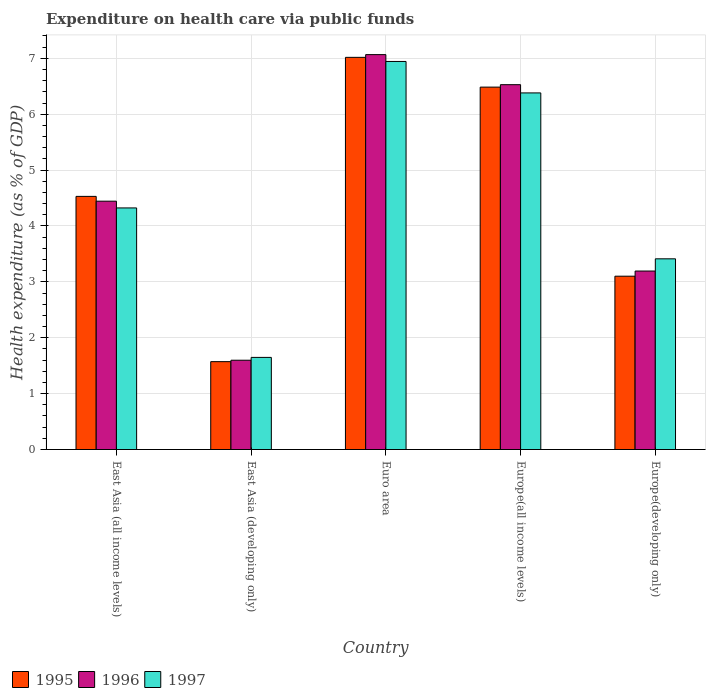How many different coloured bars are there?
Offer a terse response. 3. How many groups of bars are there?
Your response must be concise. 5. Are the number of bars per tick equal to the number of legend labels?
Provide a short and direct response. Yes. How many bars are there on the 3rd tick from the right?
Your answer should be very brief. 3. What is the label of the 4th group of bars from the left?
Ensure brevity in your answer.  Europe(all income levels). In how many cases, is the number of bars for a given country not equal to the number of legend labels?
Keep it short and to the point. 0. What is the expenditure made on health care in 1995 in Euro area?
Give a very brief answer. 7.02. Across all countries, what is the maximum expenditure made on health care in 1997?
Give a very brief answer. 6.94. Across all countries, what is the minimum expenditure made on health care in 1995?
Keep it short and to the point. 1.57. In which country was the expenditure made on health care in 1995 maximum?
Keep it short and to the point. Euro area. In which country was the expenditure made on health care in 1996 minimum?
Your answer should be compact. East Asia (developing only). What is the total expenditure made on health care in 1996 in the graph?
Offer a very short reply. 22.83. What is the difference between the expenditure made on health care in 1996 in East Asia (developing only) and that in Europe(all income levels)?
Your answer should be compact. -4.93. What is the difference between the expenditure made on health care in 1995 in East Asia (all income levels) and the expenditure made on health care in 1997 in Euro area?
Provide a short and direct response. -2.41. What is the average expenditure made on health care in 1995 per country?
Ensure brevity in your answer.  4.54. What is the difference between the expenditure made on health care of/in 1996 and expenditure made on health care of/in 1997 in East Asia (developing only)?
Provide a succinct answer. -0.05. What is the ratio of the expenditure made on health care in 1996 in East Asia (developing only) to that in Euro area?
Your response must be concise. 0.23. Is the expenditure made on health care in 1996 in Europe(all income levels) less than that in Europe(developing only)?
Make the answer very short. No. What is the difference between the highest and the second highest expenditure made on health care in 1997?
Ensure brevity in your answer.  -2.62. What is the difference between the highest and the lowest expenditure made on health care in 1996?
Give a very brief answer. 5.47. In how many countries, is the expenditure made on health care in 1995 greater than the average expenditure made on health care in 1995 taken over all countries?
Keep it short and to the point. 2. What does the 2nd bar from the left in East Asia (developing only) represents?
Provide a succinct answer. 1996. What does the 2nd bar from the right in Europe(all income levels) represents?
Offer a very short reply. 1996. Is it the case that in every country, the sum of the expenditure made on health care in 1996 and expenditure made on health care in 1995 is greater than the expenditure made on health care in 1997?
Your answer should be compact. Yes. How many bars are there?
Provide a short and direct response. 15. How many countries are there in the graph?
Offer a very short reply. 5. Does the graph contain grids?
Provide a succinct answer. Yes. How are the legend labels stacked?
Make the answer very short. Horizontal. What is the title of the graph?
Ensure brevity in your answer.  Expenditure on health care via public funds. What is the label or title of the Y-axis?
Offer a very short reply. Health expenditure (as % of GDP). What is the Health expenditure (as % of GDP) of 1995 in East Asia (all income levels)?
Keep it short and to the point. 4.53. What is the Health expenditure (as % of GDP) of 1996 in East Asia (all income levels)?
Ensure brevity in your answer.  4.44. What is the Health expenditure (as % of GDP) of 1997 in East Asia (all income levels)?
Ensure brevity in your answer.  4.32. What is the Health expenditure (as % of GDP) of 1995 in East Asia (developing only)?
Make the answer very short. 1.57. What is the Health expenditure (as % of GDP) of 1996 in East Asia (developing only)?
Your response must be concise. 1.6. What is the Health expenditure (as % of GDP) of 1997 in East Asia (developing only)?
Offer a terse response. 1.65. What is the Health expenditure (as % of GDP) of 1995 in Euro area?
Your answer should be very brief. 7.02. What is the Health expenditure (as % of GDP) in 1996 in Euro area?
Offer a terse response. 7.07. What is the Health expenditure (as % of GDP) of 1997 in Euro area?
Your answer should be compact. 6.94. What is the Health expenditure (as % of GDP) of 1995 in Europe(all income levels)?
Ensure brevity in your answer.  6.48. What is the Health expenditure (as % of GDP) in 1996 in Europe(all income levels)?
Provide a succinct answer. 6.53. What is the Health expenditure (as % of GDP) in 1997 in Europe(all income levels)?
Make the answer very short. 6.38. What is the Health expenditure (as % of GDP) of 1995 in Europe(developing only)?
Provide a succinct answer. 3.1. What is the Health expenditure (as % of GDP) in 1996 in Europe(developing only)?
Offer a very short reply. 3.19. What is the Health expenditure (as % of GDP) of 1997 in Europe(developing only)?
Provide a short and direct response. 3.41. Across all countries, what is the maximum Health expenditure (as % of GDP) in 1995?
Your answer should be compact. 7.02. Across all countries, what is the maximum Health expenditure (as % of GDP) in 1996?
Offer a very short reply. 7.07. Across all countries, what is the maximum Health expenditure (as % of GDP) in 1997?
Provide a short and direct response. 6.94. Across all countries, what is the minimum Health expenditure (as % of GDP) in 1995?
Keep it short and to the point. 1.57. Across all countries, what is the minimum Health expenditure (as % of GDP) in 1996?
Offer a terse response. 1.6. Across all countries, what is the minimum Health expenditure (as % of GDP) in 1997?
Keep it short and to the point. 1.65. What is the total Health expenditure (as % of GDP) in 1995 in the graph?
Offer a very short reply. 22.7. What is the total Health expenditure (as % of GDP) in 1996 in the graph?
Provide a succinct answer. 22.83. What is the total Health expenditure (as % of GDP) in 1997 in the graph?
Your answer should be very brief. 22.71. What is the difference between the Health expenditure (as % of GDP) in 1995 in East Asia (all income levels) and that in East Asia (developing only)?
Ensure brevity in your answer.  2.96. What is the difference between the Health expenditure (as % of GDP) of 1996 in East Asia (all income levels) and that in East Asia (developing only)?
Your answer should be very brief. 2.85. What is the difference between the Health expenditure (as % of GDP) in 1997 in East Asia (all income levels) and that in East Asia (developing only)?
Provide a short and direct response. 2.67. What is the difference between the Health expenditure (as % of GDP) of 1995 in East Asia (all income levels) and that in Euro area?
Offer a terse response. -2.49. What is the difference between the Health expenditure (as % of GDP) of 1996 in East Asia (all income levels) and that in Euro area?
Keep it short and to the point. -2.62. What is the difference between the Health expenditure (as % of GDP) in 1997 in East Asia (all income levels) and that in Euro area?
Make the answer very short. -2.62. What is the difference between the Health expenditure (as % of GDP) in 1995 in East Asia (all income levels) and that in Europe(all income levels)?
Your answer should be very brief. -1.95. What is the difference between the Health expenditure (as % of GDP) of 1996 in East Asia (all income levels) and that in Europe(all income levels)?
Ensure brevity in your answer.  -2.08. What is the difference between the Health expenditure (as % of GDP) of 1997 in East Asia (all income levels) and that in Europe(all income levels)?
Give a very brief answer. -2.06. What is the difference between the Health expenditure (as % of GDP) in 1995 in East Asia (all income levels) and that in Europe(developing only)?
Offer a terse response. 1.43. What is the difference between the Health expenditure (as % of GDP) of 1996 in East Asia (all income levels) and that in Europe(developing only)?
Your answer should be compact. 1.25. What is the difference between the Health expenditure (as % of GDP) in 1997 in East Asia (all income levels) and that in Europe(developing only)?
Make the answer very short. 0.91. What is the difference between the Health expenditure (as % of GDP) of 1995 in East Asia (developing only) and that in Euro area?
Make the answer very short. -5.44. What is the difference between the Health expenditure (as % of GDP) of 1996 in East Asia (developing only) and that in Euro area?
Keep it short and to the point. -5.47. What is the difference between the Health expenditure (as % of GDP) of 1997 in East Asia (developing only) and that in Euro area?
Ensure brevity in your answer.  -5.29. What is the difference between the Health expenditure (as % of GDP) of 1995 in East Asia (developing only) and that in Europe(all income levels)?
Offer a very short reply. -4.91. What is the difference between the Health expenditure (as % of GDP) in 1996 in East Asia (developing only) and that in Europe(all income levels)?
Offer a very short reply. -4.93. What is the difference between the Health expenditure (as % of GDP) in 1997 in East Asia (developing only) and that in Europe(all income levels)?
Ensure brevity in your answer.  -4.73. What is the difference between the Health expenditure (as % of GDP) of 1995 in East Asia (developing only) and that in Europe(developing only)?
Your response must be concise. -1.53. What is the difference between the Health expenditure (as % of GDP) in 1996 in East Asia (developing only) and that in Europe(developing only)?
Keep it short and to the point. -1.6. What is the difference between the Health expenditure (as % of GDP) of 1997 in East Asia (developing only) and that in Europe(developing only)?
Make the answer very short. -1.76. What is the difference between the Health expenditure (as % of GDP) in 1995 in Euro area and that in Europe(all income levels)?
Your response must be concise. 0.53. What is the difference between the Health expenditure (as % of GDP) in 1996 in Euro area and that in Europe(all income levels)?
Provide a succinct answer. 0.54. What is the difference between the Health expenditure (as % of GDP) of 1997 in Euro area and that in Europe(all income levels)?
Provide a succinct answer. 0.56. What is the difference between the Health expenditure (as % of GDP) in 1995 in Euro area and that in Europe(developing only)?
Make the answer very short. 3.92. What is the difference between the Health expenditure (as % of GDP) of 1996 in Euro area and that in Europe(developing only)?
Offer a very short reply. 3.87. What is the difference between the Health expenditure (as % of GDP) of 1997 in Euro area and that in Europe(developing only)?
Give a very brief answer. 3.53. What is the difference between the Health expenditure (as % of GDP) of 1995 in Europe(all income levels) and that in Europe(developing only)?
Your answer should be compact. 3.38. What is the difference between the Health expenditure (as % of GDP) in 1996 in Europe(all income levels) and that in Europe(developing only)?
Offer a very short reply. 3.33. What is the difference between the Health expenditure (as % of GDP) in 1997 in Europe(all income levels) and that in Europe(developing only)?
Provide a short and direct response. 2.97. What is the difference between the Health expenditure (as % of GDP) in 1995 in East Asia (all income levels) and the Health expenditure (as % of GDP) in 1996 in East Asia (developing only)?
Give a very brief answer. 2.93. What is the difference between the Health expenditure (as % of GDP) in 1995 in East Asia (all income levels) and the Health expenditure (as % of GDP) in 1997 in East Asia (developing only)?
Give a very brief answer. 2.88. What is the difference between the Health expenditure (as % of GDP) in 1996 in East Asia (all income levels) and the Health expenditure (as % of GDP) in 1997 in East Asia (developing only)?
Offer a very short reply. 2.8. What is the difference between the Health expenditure (as % of GDP) in 1995 in East Asia (all income levels) and the Health expenditure (as % of GDP) in 1996 in Euro area?
Offer a terse response. -2.54. What is the difference between the Health expenditure (as % of GDP) of 1995 in East Asia (all income levels) and the Health expenditure (as % of GDP) of 1997 in Euro area?
Offer a very short reply. -2.41. What is the difference between the Health expenditure (as % of GDP) in 1996 in East Asia (all income levels) and the Health expenditure (as % of GDP) in 1997 in Euro area?
Provide a succinct answer. -2.5. What is the difference between the Health expenditure (as % of GDP) in 1995 in East Asia (all income levels) and the Health expenditure (as % of GDP) in 1996 in Europe(all income levels)?
Provide a short and direct response. -2. What is the difference between the Health expenditure (as % of GDP) in 1995 in East Asia (all income levels) and the Health expenditure (as % of GDP) in 1997 in Europe(all income levels)?
Offer a terse response. -1.85. What is the difference between the Health expenditure (as % of GDP) in 1996 in East Asia (all income levels) and the Health expenditure (as % of GDP) in 1997 in Europe(all income levels)?
Offer a terse response. -1.94. What is the difference between the Health expenditure (as % of GDP) in 1995 in East Asia (all income levels) and the Health expenditure (as % of GDP) in 1996 in Europe(developing only)?
Keep it short and to the point. 1.34. What is the difference between the Health expenditure (as % of GDP) of 1995 in East Asia (all income levels) and the Health expenditure (as % of GDP) of 1997 in Europe(developing only)?
Keep it short and to the point. 1.12. What is the difference between the Health expenditure (as % of GDP) in 1996 in East Asia (all income levels) and the Health expenditure (as % of GDP) in 1997 in Europe(developing only)?
Give a very brief answer. 1.03. What is the difference between the Health expenditure (as % of GDP) of 1995 in East Asia (developing only) and the Health expenditure (as % of GDP) of 1996 in Euro area?
Ensure brevity in your answer.  -5.49. What is the difference between the Health expenditure (as % of GDP) in 1995 in East Asia (developing only) and the Health expenditure (as % of GDP) in 1997 in Euro area?
Make the answer very short. -5.37. What is the difference between the Health expenditure (as % of GDP) of 1996 in East Asia (developing only) and the Health expenditure (as % of GDP) of 1997 in Euro area?
Provide a succinct answer. -5.35. What is the difference between the Health expenditure (as % of GDP) in 1995 in East Asia (developing only) and the Health expenditure (as % of GDP) in 1996 in Europe(all income levels)?
Your answer should be very brief. -4.96. What is the difference between the Health expenditure (as % of GDP) of 1995 in East Asia (developing only) and the Health expenditure (as % of GDP) of 1997 in Europe(all income levels)?
Your response must be concise. -4.81. What is the difference between the Health expenditure (as % of GDP) in 1996 in East Asia (developing only) and the Health expenditure (as % of GDP) in 1997 in Europe(all income levels)?
Offer a very short reply. -4.78. What is the difference between the Health expenditure (as % of GDP) of 1995 in East Asia (developing only) and the Health expenditure (as % of GDP) of 1996 in Europe(developing only)?
Keep it short and to the point. -1.62. What is the difference between the Health expenditure (as % of GDP) of 1995 in East Asia (developing only) and the Health expenditure (as % of GDP) of 1997 in Europe(developing only)?
Give a very brief answer. -1.84. What is the difference between the Health expenditure (as % of GDP) in 1996 in East Asia (developing only) and the Health expenditure (as % of GDP) in 1997 in Europe(developing only)?
Your response must be concise. -1.81. What is the difference between the Health expenditure (as % of GDP) in 1995 in Euro area and the Health expenditure (as % of GDP) in 1996 in Europe(all income levels)?
Your answer should be very brief. 0.49. What is the difference between the Health expenditure (as % of GDP) in 1995 in Euro area and the Health expenditure (as % of GDP) in 1997 in Europe(all income levels)?
Your response must be concise. 0.64. What is the difference between the Health expenditure (as % of GDP) of 1996 in Euro area and the Health expenditure (as % of GDP) of 1997 in Europe(all income levels)?
Offer a very short reply. 0.69. What is the difference between the Health expenditure (as % of GDP) in 1995 in Euro area and the Health expenditure (as % of GDP) in 1996 in Europe(developing only)?
Keep it short and to the point. 3.82. What is the difference between the Health expenditure (as % of GDP) of 1995 in Euro area and the Health expenditure (as % of GDP) of 1997 in Europe(developing only)?
Your response must be concise. 3.6. What is the difference between the Health expenditure (as % of GDP) of 1996 in Euro area and the Health expenditure (as % of GDP) of 1997 in Europe(developing only)?
Offer a very short reply. 3.65. What is the difference between the Health expenditure (as % of GDP) of 1995 in Europe(all income levels) and the Health expenditure (as % of GDP) of 1996 in Europe(developing only)?
Make the answer very short. 3.29. What is the difference between the Health expenditure (as % of GDP) in 1995 in Europe(all income levels) and the Health expenditure (as % of GDP) in 1997 in Europe(developing only)?
Ensure brevity in your answer.  3.07. What is the difference between the Health expenditure (as % of GDP) in 1996 in Europe(all income levels) and the Health expenditure (as % of GDP) in 1997 in Europe(developing only)?
Offer a very short reply. 3.12. What is the average Health expenditure (as % of GDP) of 1995 per country?
Offer a very short reply. 4.54. What is the average Health expenditure (as % of GDP) of 1996 per country?
Ensure brevity in your answer.  4.57. What is the average Health expenditure (as % of GDP) of 1997 per country?
Keep it short and to the point. 4.54. What is the difference between the Health expenditure (as % of GDP) of 1995 and Health expenditure (as % of GDP) of 1996 in East Asia (all income levels)?
Offer a terse response. 0.09. What is the difference between the Health expenditure (as % of GDP) of 1995 and Health expenditure (as % of GDP) of 1997 in East Asia (all income levels)?
Provide a succinct answer. 0.21. What is the difference between the Health expenditure (as % of GDP) in 1996 and Health expenditure (as % of GDP) in 1997 in East Asia (all income levels)?
Keep it short and to the point. 0.12. What is the difference between the Health expenditure (as % of GDP) of 1995 and Health expenditure (as % of GDP) of 1996 in East Asia (developing only)?
Keep it short and to the point. -0.03. What is the difference between the Health expenditure (as % of GDP) in 1995 and Health expenditure (as % of GDP) in 1997 in East Asia (developing only)?
Provide a succinct answer. -0.08. What is the difference between the Health expenditure (as % of GDP) of 1996 and Health expenditure (as % of GDP) of 1997 in East Asia (developing only)?
Make the answer very short. -0.05. What is the difference between the Health expenditure (as % of GDP) in 1995 and Health expenditure (as % of GDP) in 1996 in Euro area?
Your answer should be very brief. -0.05. What is the difference between the Health expenditure (as % of GDP) in 1995 and Health expenditure (as % of GDP) in 1997 in Euro area?
Keep it short and to the point. 0.07. What is the difference between the Health expenditure (as % of GDP) of 1996 and Health expenditure (as % of GDP) of 1997 in Euro area?
Offer a very short reply. 0.12. What is the difference between the Health expenditure (as % of GDP) of 1995 and Health expenditure (as % of GDP) of 1996 in Europe(all income levels)?
Provide a succinct answer. -0.04. What is the difference between the Health expenditure (as % of GDP) of 1995 and Health expenditure (as % of GDP) of 1997 in Europe(all income levels)?
Make the answer very short. 0.1. What is the difference between the Health expenditure (as % of GDP) in 1996 and Health expenditure (as % of GDP) in 1997 in Europe(all income levels)?
Offer a terse response. 0.15. What is the difference between the Health expenditure (as % of GDP) in 1995 and Health expenditure (as % of GDP) in 1996 in Europe(developing only)?
Provide a succinct answer. -0.09. What is the difference between the Health expenditure (as % of GDP) in 1995 and Health expenditure (as % of GDP) in 1997 in Europe(developing only)?
Your answer should be compact. -0.31. What is the difference between the Health expenditure (as % of GDP) of 1996 and Health expenditure (as % of GDP) of 1997 in Europe(developing only)?
Provide a short and direct response. -0.22. What is the ratio of the Health expenditure (as % of GDP) in 1995 in East Asia (all income levels) to that in East Asia (developing only)?
Provide a short and direct response. 2.88. What is the ratio of the Health expenditure (as % of GDP) of 1996 in East Asia (all income levels) to that in East Asia (developing only)?
Provide a succinct answer. 2.78. What is the ratio of the Health expenditure (as % of GDP) of 1997 in East Asia (all income levels) to that in East Asia (developing only)?
Offer a very short reply. 2.62. What is the ratio of the Health expenditure (as % of GDP) of 1995 in East Asia (all income levels) to that in Euro area?
Offer a terse response. 0.65. What is the ratio of the Health expenditure (as % of GDP) of 1996 in East Asia (all income levels) to that in Euro area?
Offer a terse response. 0.63. What is the ratio of the Health expenditure (as % of GDP) in 1997 in East Asia (all income levels) to that in Euro area?
Your answer should be very brief. 0.62. What is the ratio of the Health expenditure (as % of GDP) in 1995 in East Asia (all income levels) to that in Europe(all income levels)?
Provide a succinct answer. 0.7. What is the ratio of the Health expenditure (as % of GDP) of 1996 in East Asia (all income levels) to that in Europe(all income levels)?
Ensure brevity in your answer.  0.68. What is the ratio of the Health expenditure (as % of GDP) of 1997 in East Asia (all income levels) to that in Europe(all income levels)?
Your response must be concise. 0.68. What is the ratio of the Health expenditure (as % of GDP) in 1995 in East Asia (all income levels) to that in Europe(developing only)?
Provide a succinct answer. 1.46. What is the ratio of the Health expenditure (as % of GDP) of 1996 in East Asia (all income levels) to that in Europe(developing only)?
Provide a succinct answer. 1.39. What is the ratio of the Health expenditure (as % of GDP) in 1997 in East Asia (all income levels) to that in Europe(developing only)?
Make the answer very short. 1.27. What is the ratio of the Health expenditure (as % of GDP) in 1995 in East Asia (developing only) to that in Euro area?
Make the answer very short. 0.22. What is the ratio of the Health expenditure (as % of GDP) of 1996 in East Asia (developing only) to that in Euro area?
Keep it short and to the point. 0.23. What is the ratio of the Health expenditure (as % of GDP) of 1997 in East Asia (developing only) to that in Euro area?
Your answer should be compact. 0.24. What is the ratio of the Health expenditure (as % of GDP) of 1995 in East Asia (developing only) to that in Europe(all income levels)?
Keep it short and to the point. 0.24. What is the ratio of the Health expenditure (as % of GDP) of 1996 in East Asia (developing only) to that in Europe(all income levels)?
Your answer should be very brief. 0.24. What is the ratio of the Health expenditure (as % of GDP) in 1997 in East Asia (developing only) to that in Europe(all income levels)?
Keep it short and to the point. 0.26. What is the ratio of the Health expenditure (as % of GDP) of 1995 in East Asia (developing only) to that in Europe(developing only)?
Your answer should be very brief. 0.51. What is the ratio of the Health expenditure (as % of GDP) of 1996 in East Asia (developing only) to that in Europe(developing only)?
Give a very brief answer. 0.5. What is the ratio of the Health expenditure (as % of GDP) in 1997 in East Asia (developing only) to that in Europe(developing only)?
Offer a terse response. 0.48. What is the ratio of the Health expenditure (as % of GDP) in 1995 in Euro area to that in Europe(all income levels)?
Make the answer very short. 1.08. What is the ratio of the Health expenditure (as % of GDP) of 1996 in Euro area to that in Europe(all income levels)?
Offer a very short reply. 1.08. What is the ratio of the Health expenditure (as % of GDP) in 1997 in Euro area to that in Europe(all income levels)?
Your answer should be compact. 1.09. What is the ratio of the Health expenditure (as % of GDP) in 1995 in Euro area to that in Europe(developing only)?
Provide a short and direct response. 2.26. What is the ratio of the Health expenditure (as % of GDP) of 1996 in Euro area to that in Europe(developing only)?
Provide a succinct answer. 2.21. What is the ratio of the Health expenditure (as % of GDP) of 1997 in Euro area to that in Europe(developing only)?
Give a very brief answer. 2.03. What is the ratio of the Health expenditure (as % of GDP) in 1995 in Europe(all income levels) to that in Europe(developing only)?
Provide a succinct answer. 2.09. What is the ratio of the Health expenditure (as % of GDP) of 1996 in Europe(all income levels) to that in Europe(developing only)?
Your answer should be very brief. 2.04. What is the ratio of the Health expenditure (as % of GDP) of 1997 in Europe(all income levels) to that in Europe(developing only)?
Ensure brevity in your answer.  1.87. What is the difference between the highest and the second highest Health expenditure (as % of GDP) in 1995?
Keep it short and to the point. 0.53. What is the difference between the highest and the second highest Health expenditure (as % of GDP) of 1996?
Your answer should be very brief. 0.54. What is the difference between the highest and the second highest Health expenditure (as % of GDP) of 1997?
Your response must be concise. 0.56. What is the difference between the highest and the lowest Health expenditure (as % of GDP) of 1995?
Provide a short and direct response. 5.44. What is the difference between the highest and the lowest Health expenditure (as % of GDP) in 1996?
Provide a short and direct response. 5.47. What is the difference between the highest and the lowest Health expenditure (as % of GDP) in 1997?
Offer a very short reply. 5.29. 